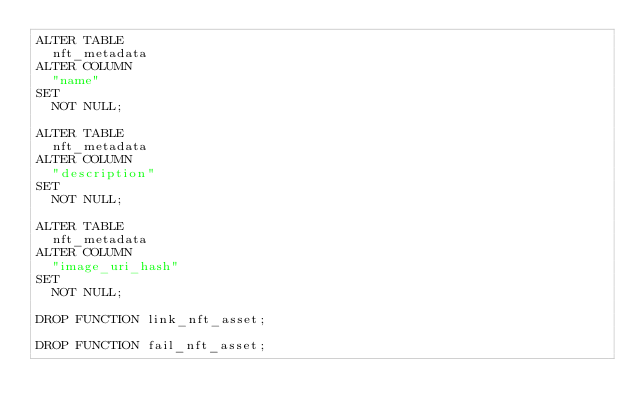<code> <loc_0><loc_0><loc_500><loc_500><_SQL_>ALTER TABLE
  nft_metadata
ALTER COLUMN
  "name"
SET
  NOT NULL;

ALTER TABLE
  nft_metadata
ALTER COLUMN
  "description"
SET
  NOT NULL;

ALTER TABLE
  nft_metadata
ALTER COLUMN
  "image_uri_hash"
SET
  NOT NULL;

DROP FUNCTION link_nft_asset;

DROP FUNCTION fail_nft_asset;
</code> 